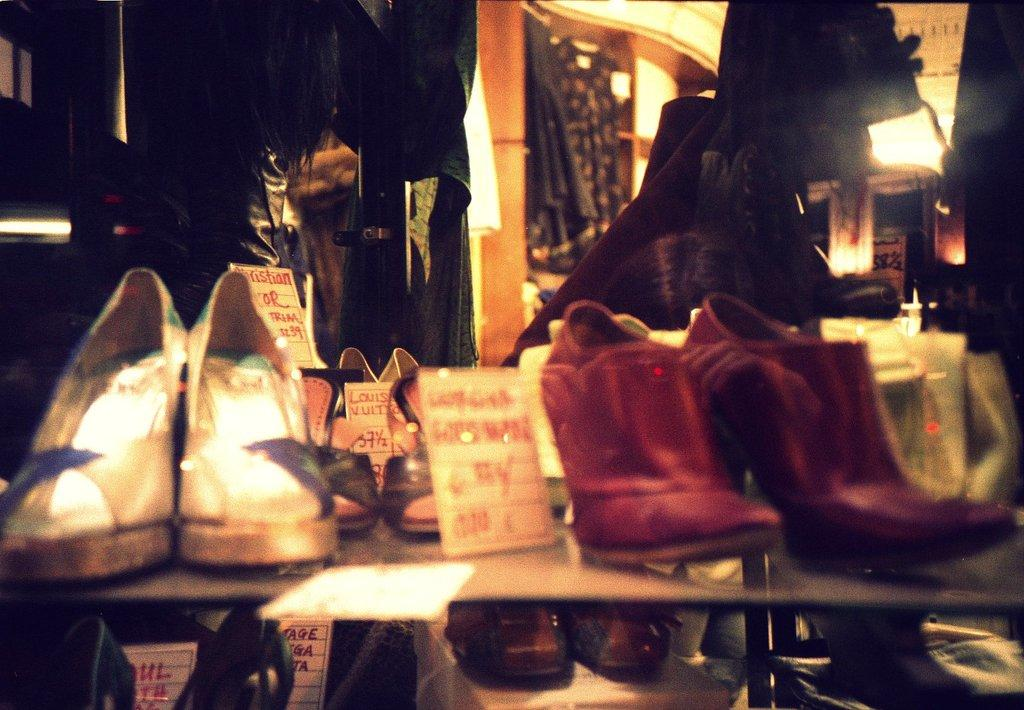What type of objects can be seen in the image? There are shoes and clothes hanging in the image. Can you describe the clothes that are hanging? Unfortunately, the facts provided do not give any details about the clothes. Where are the shoes located in the image? The facts do not specify the location of the shoes within the image. How many elbows can be seen in the image? There are no elbows visible in the image. What type of cars are parked near the clothes in the image? There is no mention of cars in the image; it only features shoes and clothes hanging. 